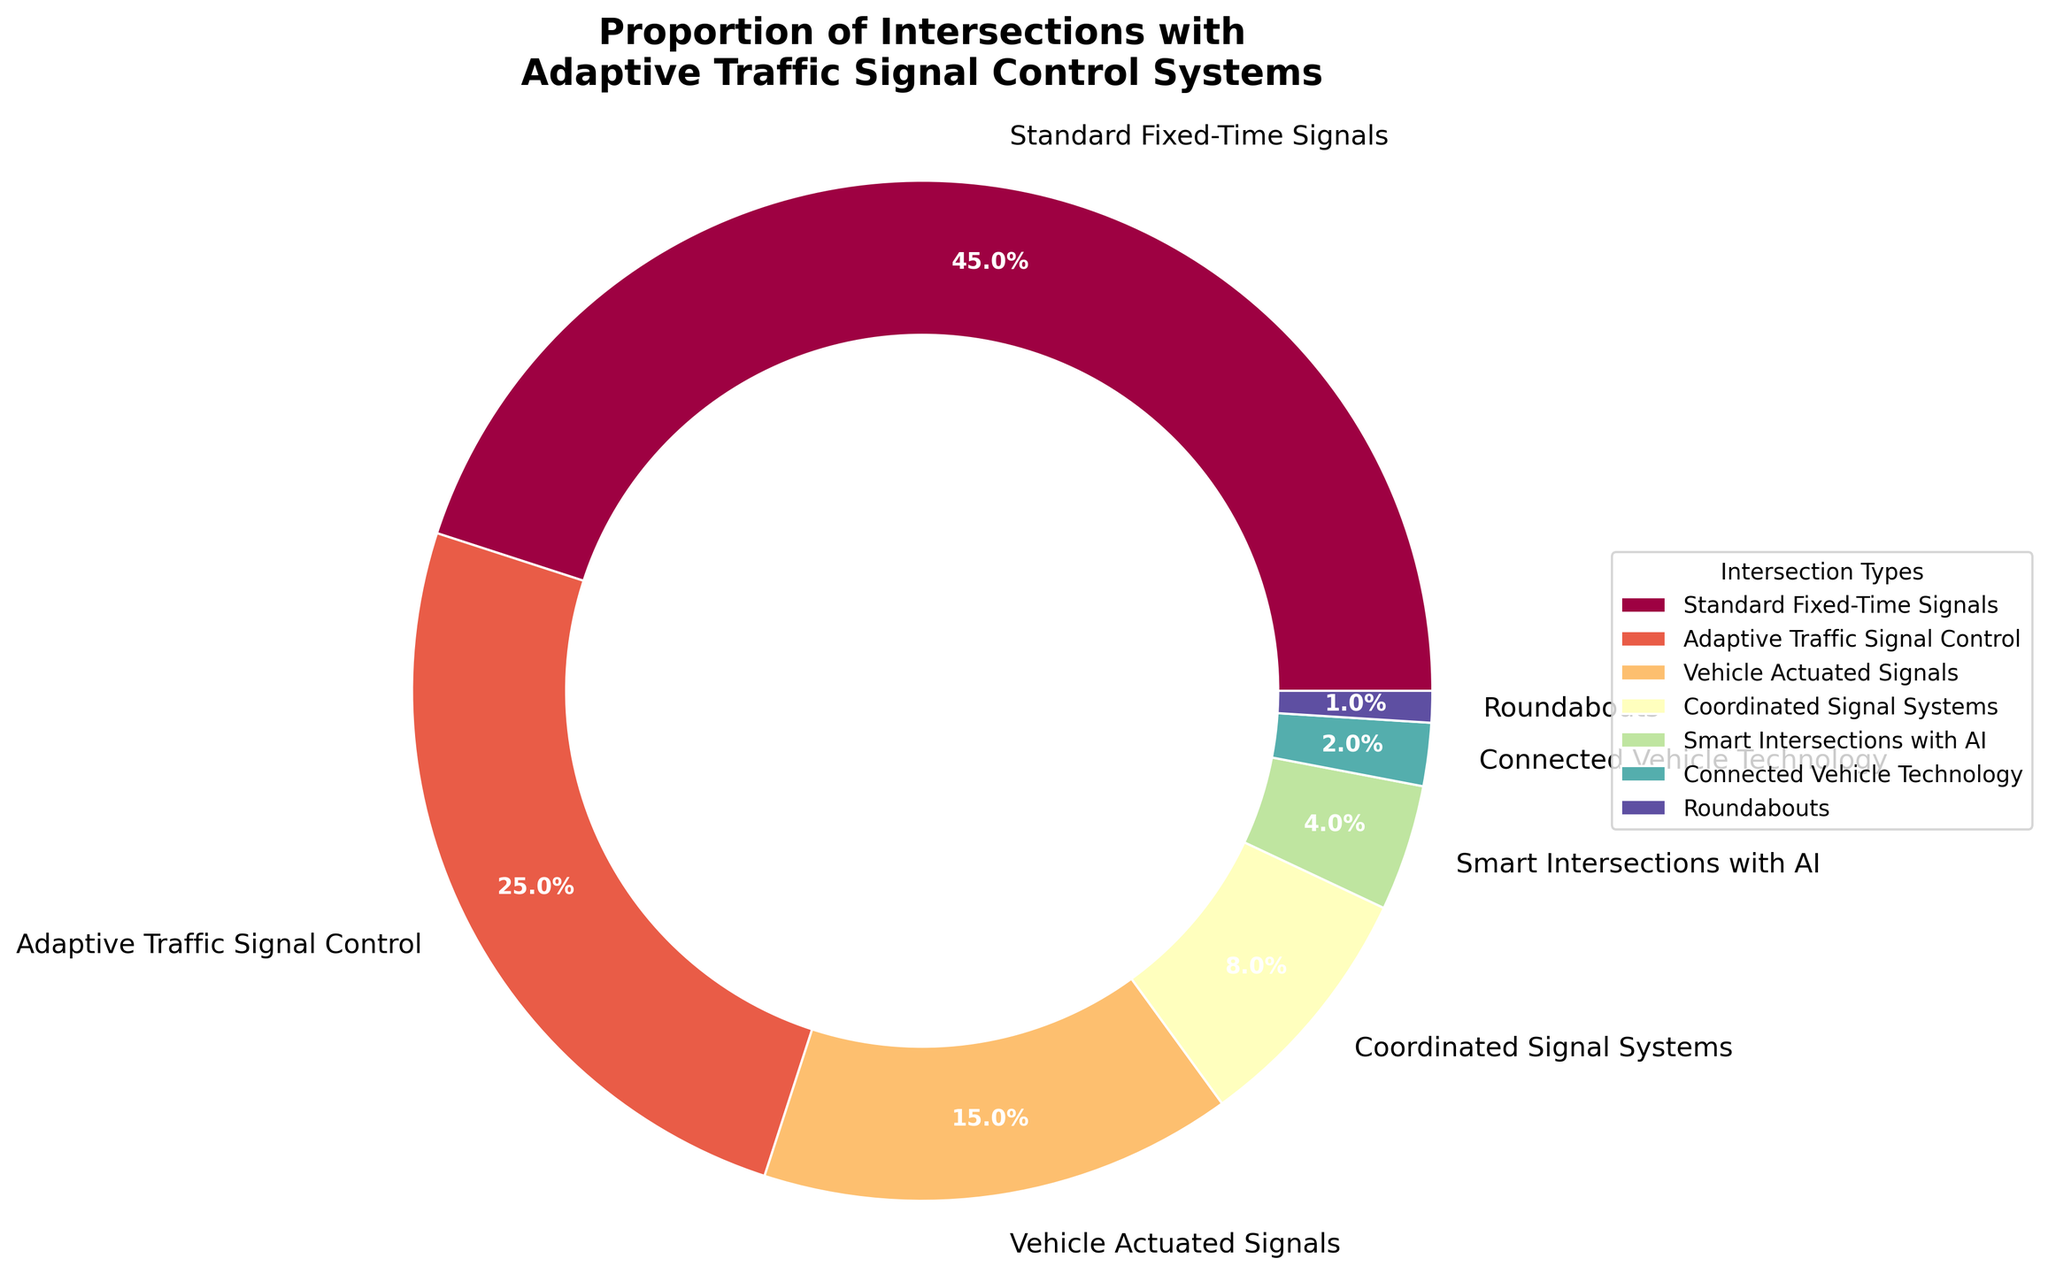Which type of intersection has the highest percentage? By looking at the figure, the largest slice of the pie chart can be identified by its label, which corresponds to the intersection with the highest percentage.
Answer: Standard Fixed-Time Signals What proportion of intersections are equipped with adaptive traffic signal control systems? The wedge labeled "Adaptive Traffic Signal Control" indicates the proportion, and the percentage is written within the wedge on the pie chart.
Answer: 25% How much larger is the proportion of Standard Fixed-Time Signals compared to Vehicle Actuated Signals? Subtract the percentage of Vehicle Actuated Signals from the percentage of Standard Fixed-Time Signals. 45% (Standard Fixed-Time Signals) - 15% (Vehicle Actuated Signals) = 30%.
Answer: 30% What is the combined percentage of intersections utilizing Smart Intersections with AI and Connected Vehicle Technology? Add the percentages of Smart Intersections with AI and Connected Vehicle Technology. 4% (Smart Intersections with AI) + 2% (Connected Vehicle Technology) = 6%.
Answer: 6% Which Intersection type has the smallest proportion? By looking at the figure, identify the smallest slice of the pie chart and its corresponding label.
Answer: Roundabouts How do the proportions of Adaptive Traffic Signal Control systems and Coordinated Signal Systems compare? Compare the percentages of Adaptive Traffic Signal Control (25%) and Coordinated Signal Systems (8%). Adaptive Traffic Signal Control systems have a higher percentage.
Answer: Adaptive Traffic Signal Control is higher What is the difference in percentage between Connected Vehicle Technology and Roundabouts? Subtract the percentage of Roundabouts from the percentage of Connected Vehicle Technology. 2% (Connected Vehicle Technology) - 1% (Roundabouts) = 1%.
Answer: 1% What percentage of intersections do not have any adaptive or smart technologies (sum of Standard Fixed-Time Signals and Vehicle Actuated Signals)? Add the percentages of Standard Fixed-Time Signals and Vehicle Actuated Signals. 45% (Standard Fixed-Time Signals) + 15% (Vehicle Actuated Signals) = 60%.
Answer: 60% What is the total percentage of intersections that use technologies other than Standard Fixed-Time Signals? Subtract the percentage of Standard Fixed-Time Signals from 100%. 100% - 45% = 55%.
Answer: 55% Compare the combined percentage of all intelligent or adaptive technologies (Adaptive Traffic Signal Control, Smart Intersections with AI, and Connected Vehicle Technology) with the percentage of Standard Fixed-Time Signals. Add the percentages of Adaptive Traffic Signal Control (25%), Smart Intersections with AI (4%), and Connected Vehicle Technology (2%), then compare this sum to the percentage of Standard Fixed-Time Signals. 25% + 4% + 2% = 31%. 31% (All intelligent/adaptive technologies) is less than 45% (Standard Fixed-Time Signals).
Answer: 31% is less than 45% 